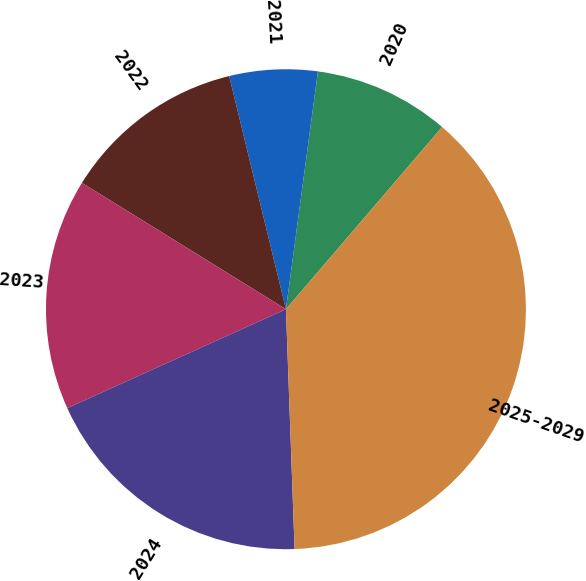Convert chart to OTSL. <chart><loc_0><loc_0><loc_500><loc_500><pie_chart><fcel>2020<fcel>2021<fcel>2022<fcel>2023<fcel>2024<fcel>2025-2029<nl><fcel>9.15%<fcel>5.93%<fcel>12.37%<fcel>15.59%<fcel>18.81%<fcel>38.15%<nl></chart> 